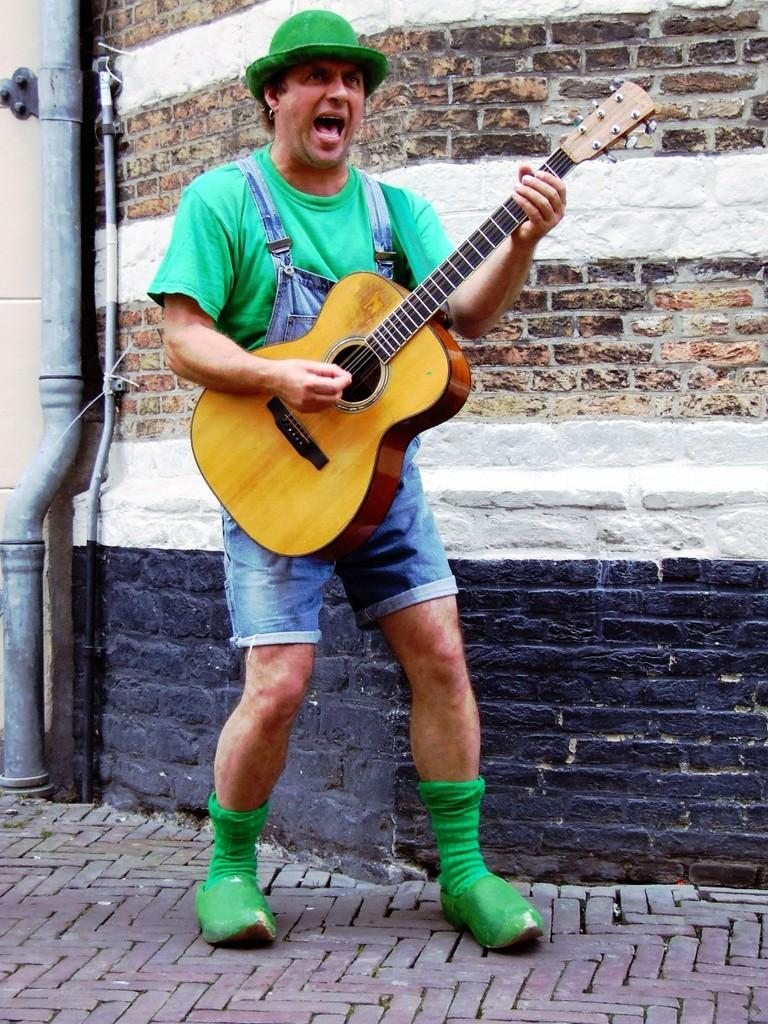What is the person in the image doing? The person is standing, playing a guitar, and singing a song. What object is the person holding in the image? The person is holding a guitar in the image. What can be seen in the background of the image? There is a pipe visible in the background. What type of headwear is the person wearing? The person is wearing a hat in the image. How many people are in the group that is sitting on the seat in the image? There is no group or seat present in the image; it features a person playing a guitar and singing a song. 